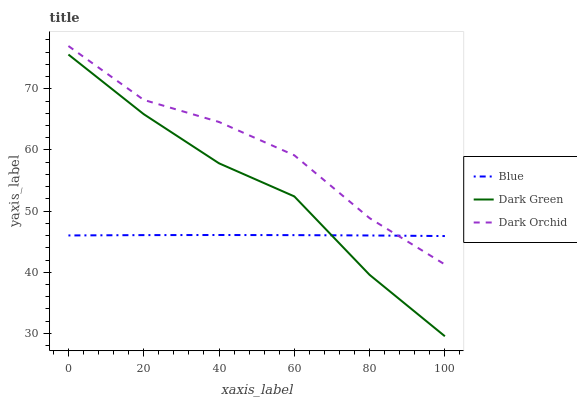Does Blue have the minimum area under the curve?
Answer yes or no. Yes. Does Dark Orchid have the maximum area under the curve?
Answer yes or no. Yes. Does Dark Green have the minimum area under the curve?
Answer yes or no. No. Does Dark Green have the maximum area under the curve?
Answer yes or no. No. Is Blue the smoothest?
Answer yes or no. Yes. Is Dark Orchid the roughest?
Answer yes or no. Yes. Is Dark Green the smoothest?
Answer yes or no. No. Is Dark Green the roughest?
Answer yes or no. No. Does Dark Orchid have the lowest value?
Answer yes or no. No. Does Dark Orchid have the highest value?
Answer yes or no. Yes. Does Dark Green have the highest value?
Answer yes or no. No. Is Dark Green less than Dark Orchid?
Answer yes or no. Yes. Is Dark Orchid greater than Dark Green?
Answer yes or no. Yes. Does Blue intersect Dark Green?
Answer yes or no. Yes. Is Blue less than Dark Green?
Answer yes or no. No. Is Blue greater than Dark Green?
Answer yes or no. No. Does Dark Green intersect Dark Orchid?
Answer yes or no. No. 